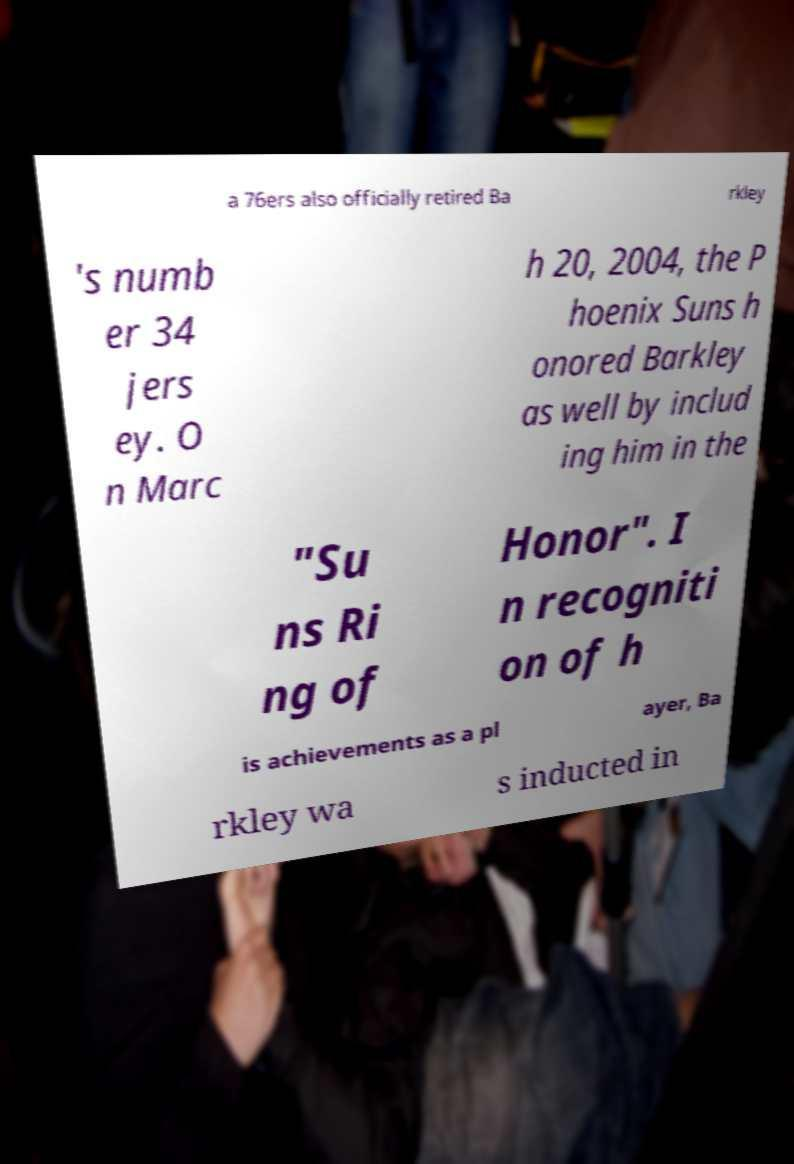There's text embedded in this image that I need extracted. Can you transcribe it verbatim? a 76ers also officially retired Ba rkley 's numb er 34 jers ey. O n Marc h 20, 2004, the P hoenix Suns h onored Barkley as well by includ ing him in the "Su ns Ri ng of Honor". I n recogniti on of h is achievements as a pl ayer, Ba rkley wa s inducted in 